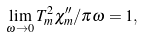Convert formula to latex. <formula><loc_0><loc_0><loc_500><loc_500>\lim _ { \omega \to 0 } T _ { m } ^ { 2 } \chi ^ { \prime \prime } _ { m } / \pi \omega = 1 ,</formula> 